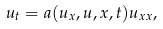Convert formula to latex. <formula><loc_0><loc_0><loc_500><loc_500>u _ { t } = a ( u _ { x } , u , x , t ) u _ { x x } ,</formula> 